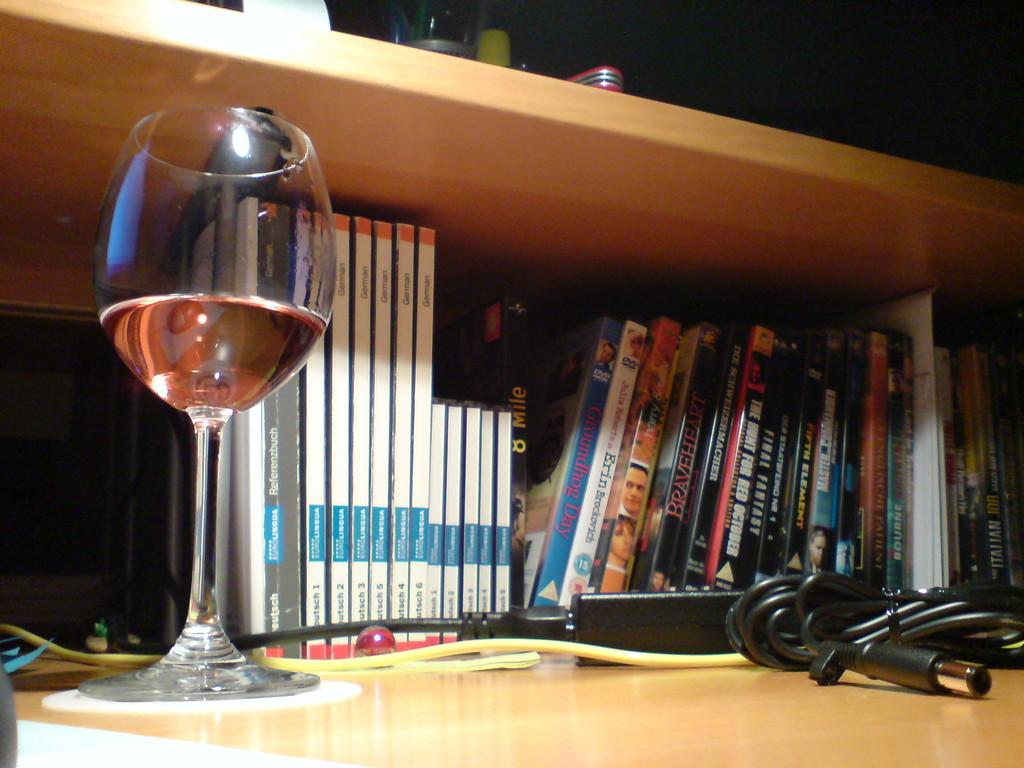How are the books arranged in the image? The books are arranged in a sequence manner in a rack. What electronic device might the adapter be used for? The adapter's purpose cannot be determined from the image alone, but it is commonly used for charging or connecting electronic devices. What is in the wine glass in the image? There is wine in the wine glass in the image. What type of glass is at the top of the image? There is a glass at the top of the image, but its specific type cannot be determined from the image alone. What type of ground can be seen beneath the books in the image? There is no ground visible beneath the books in the image; they are arranged on a rack. What is the weight of the steel used to make the adapter in the image? There is no steel present in the image, and the weight of the adapter cannot be determined from the image alone. 